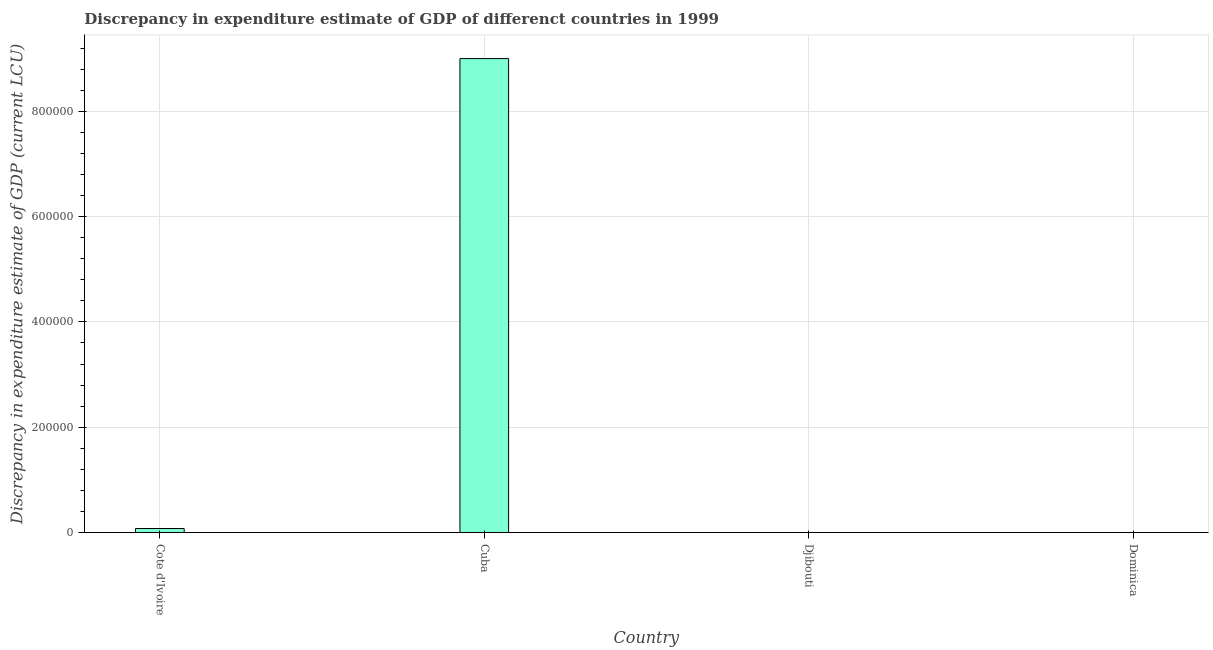Does the graph contain grids?
Keep it short and to the point. Yes. What is the title of the graph?
Provide a succinct answer. Discrepancy in expenditure estimate of GDP of differenct countries in 1999. What is the label or title of the X-axis?
Give a very brief answer. Country. What is the label or title of the Y-axis?
Keep it short and to the point. Discrepancy in expenditure estimate of GDP (current LCU). What is the discrepancy in expenditure estimate of gdp in Cuba?
Offer a terse response. 9.00e+05. Across all countries, what is the minimum discrepancy in expenditure estimate of gdp?
Provide a succinct answer. 0. In which country was the discrepancy in expenditure estimate of gdp maximum?
Ensure brevity in your answer.  Cuba. What is the sum of the discrepancy in expenditure estimate of gdp?
Your answer should be compact. 9.00e+05. What is the average discrepancy in expenditure estimate of gdp per country?
Ensure brevity in your answer.  2.25e+05. What is the median discrepancy in expenditure estimate of gdp?
Keep it short and to the point. 0. What is the difference between the highest and the lowest discrepancy in expenditure estimate of gdp?
Provide a succinct answer. 9.00e+05. How many bars are there?
Give a very brief answer. 1. Are all the bars in the graph horizontal?
Keep it short and to the point. No. How many countries are there in the graph?
Make the answer very short. 4. What is the difference between two consecutive major ticks on the Y-axis?
Provide a succinct answer. 2.00e+05. Are the values on the major ticks of Y-axis written in scientific E-notation?
Give a very brief answer. No. What is the Discrepancy in expenditure estimate of GDP (current LCU) of Djibouti?
Your answer should be very brief. 0. What is the Discrepancy in expenditure estimate of GDP (current LCU) in Dominica?
Your answer should be very brief. 0. 